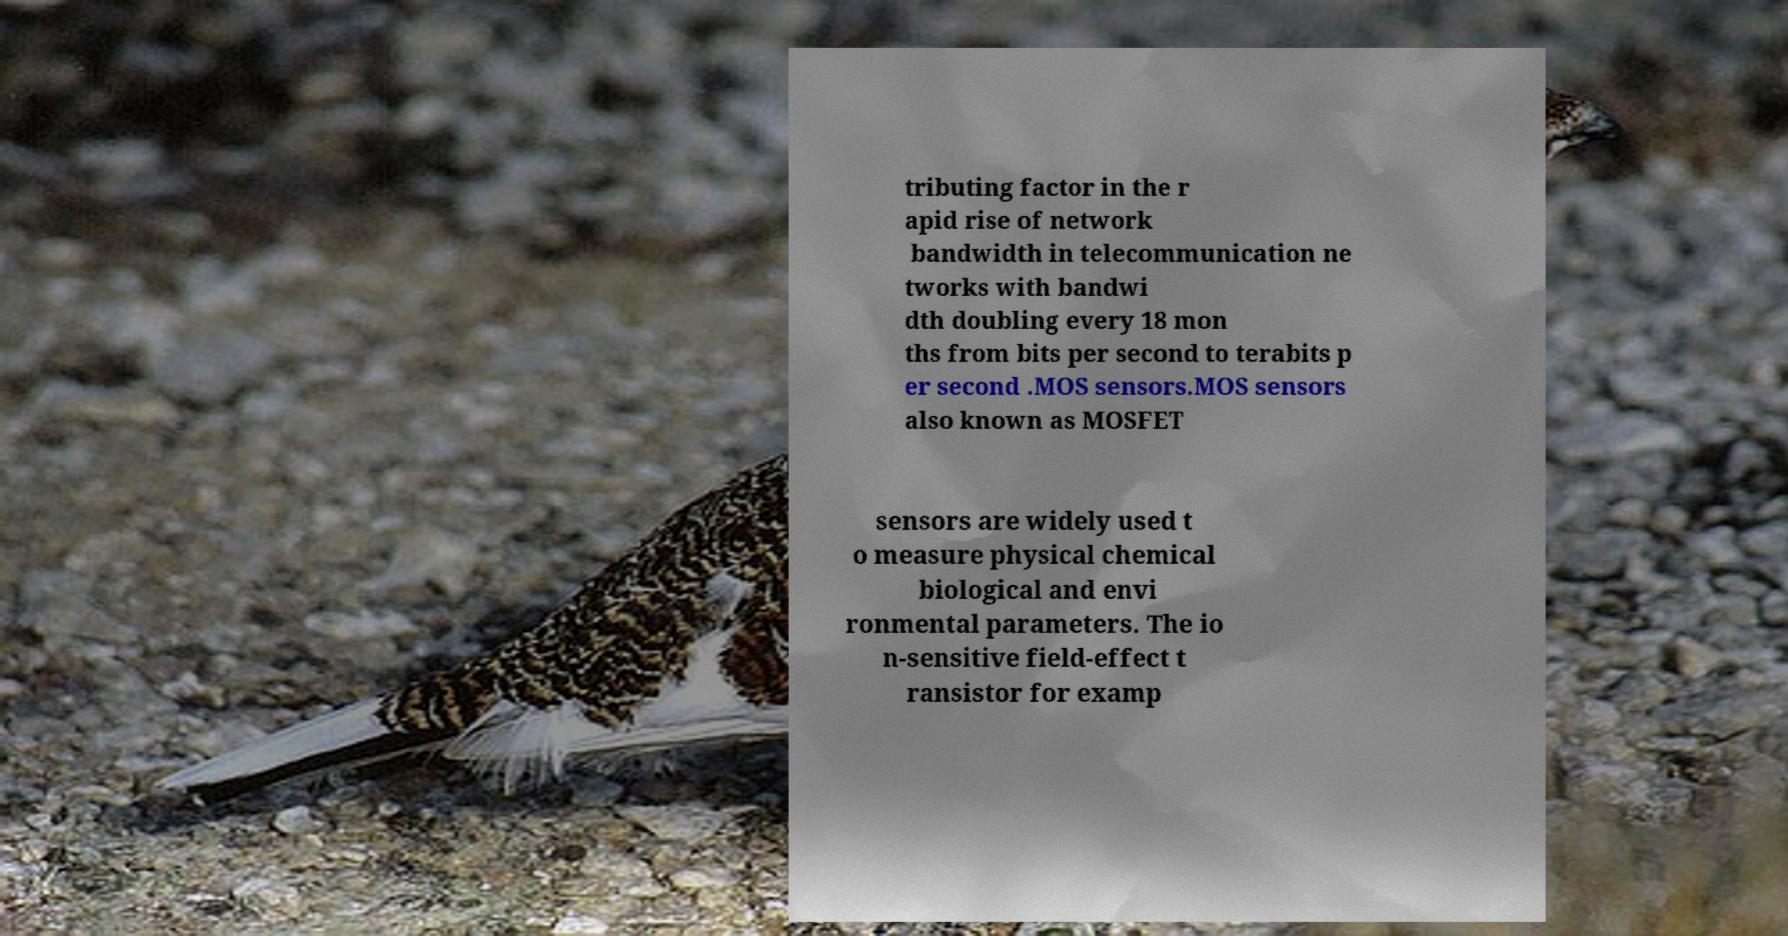Please read and relay the text visible in this image. What does it say? tributing factor in the r apid rise of network bandwidth in telecommunication ne tworks with bandwi dth doubling every 18 mon ths from bits per second to terabits p er second .MOS sensors.MOS sensors also known as MOSFET sensors are widely used t o measure physical chemical biological and envi ronmental parameters. The io n-sensitive field-effect t ransistor for examp 